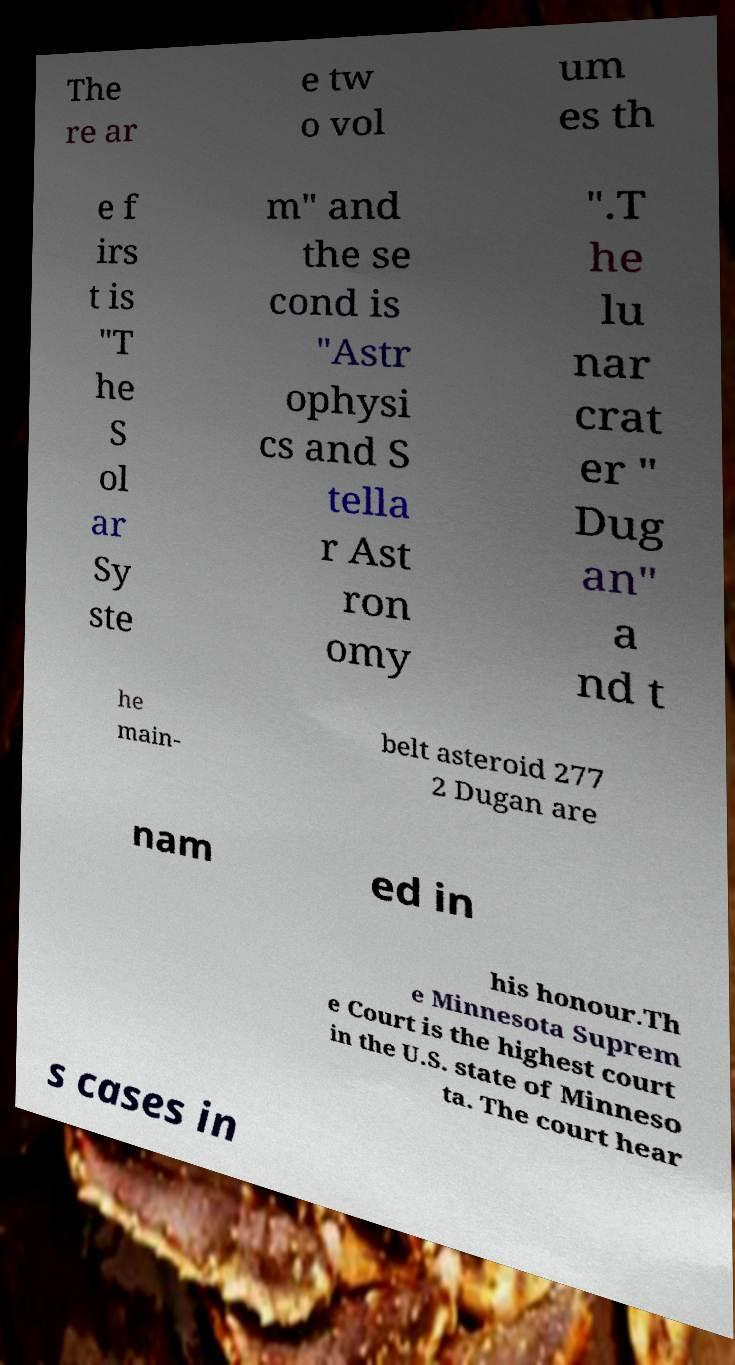Please read and relay the text visible in this image. What does it say? The re ar e tw o vol um es th e f irs t is "T he S ol ar Sy ste m" and the se cond is "Astr ophysi cs and S tella r Ast ron omy ".T he lu nar crat er " Dug an" a nd t he main- belt asteroid 277 2 Dugan are nam ed in his honour.Th e Minnesota Suprem e Court is the highest court in the U.S. state of Minneso ta. The court hear s cases in 